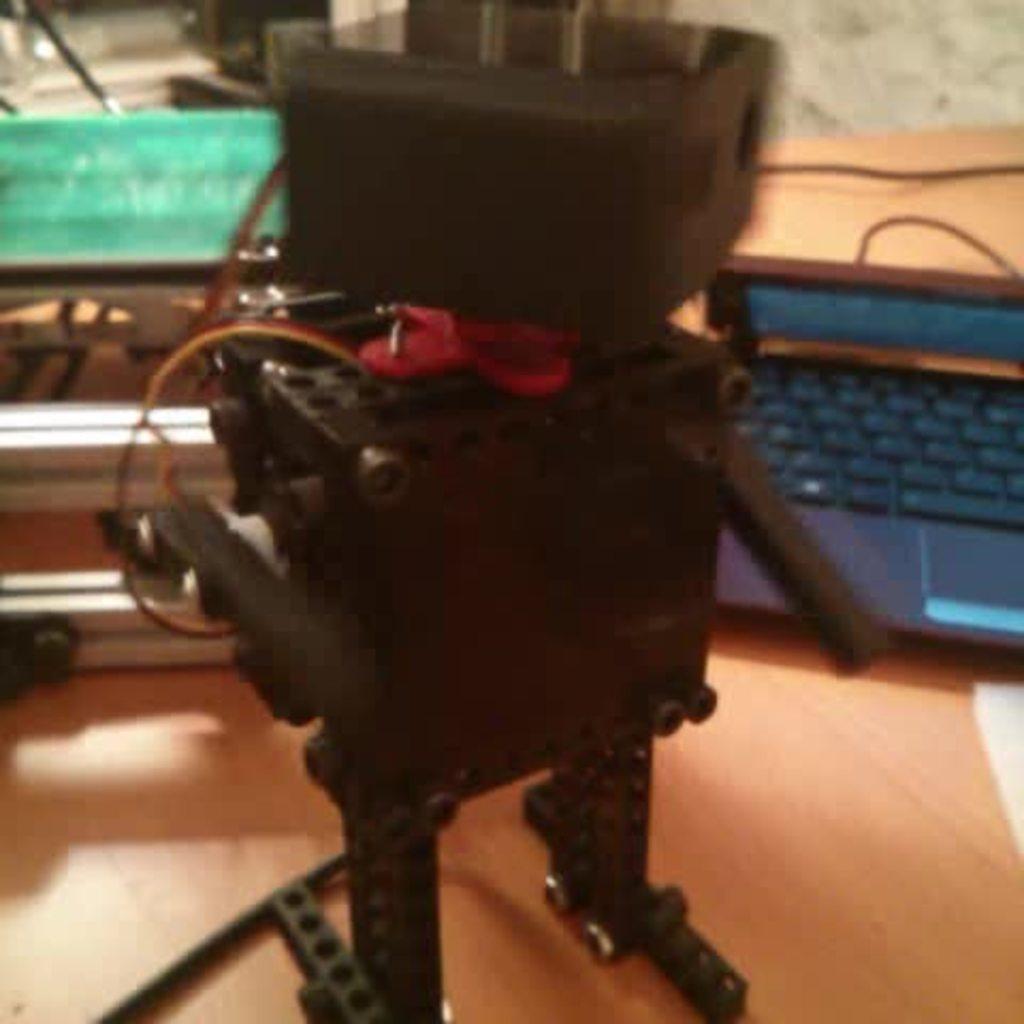How would you summarize this image in a sentence or two? Here in this picture we can see a robot present on the table over there and we can also see a laptop and other things present behind it over there. 